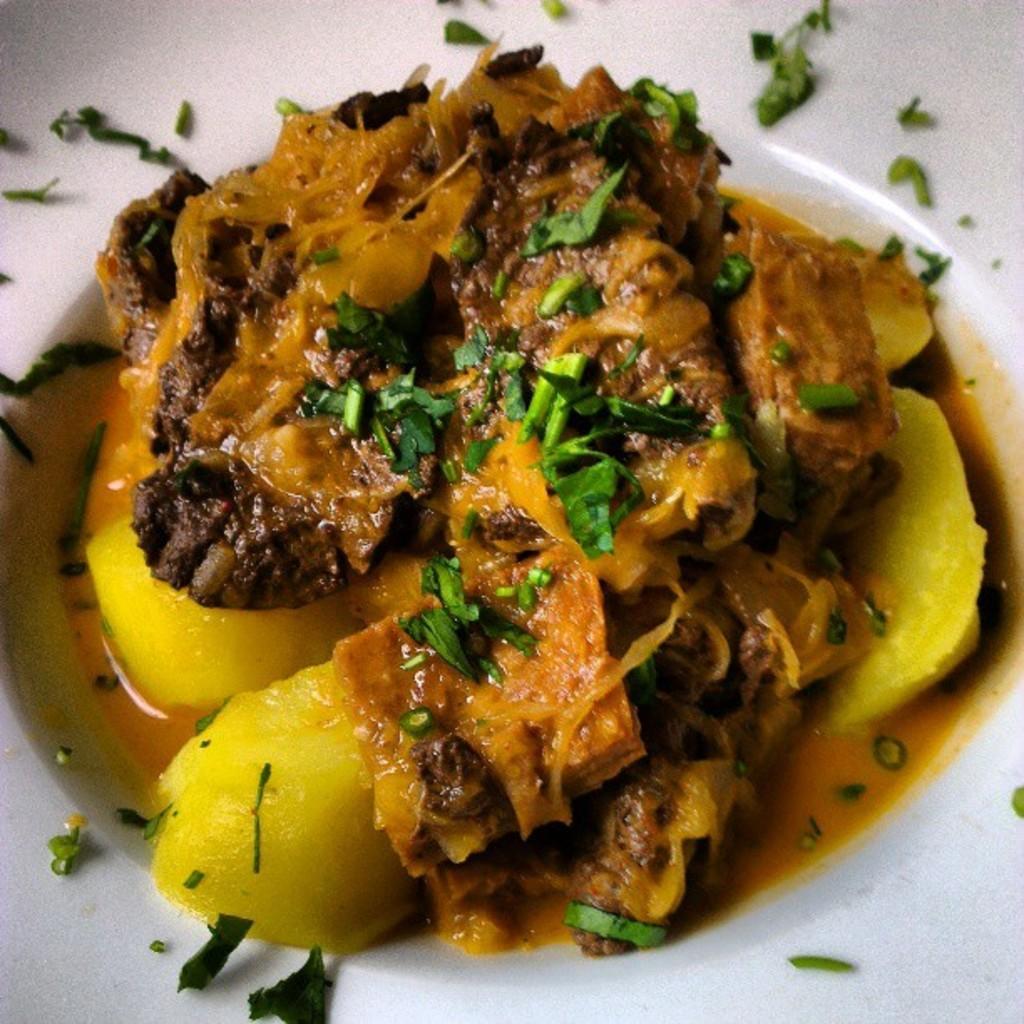In one or two sentences, can you explain what this image depicts? In the picture I can see some food item is kept on the white color plate. 